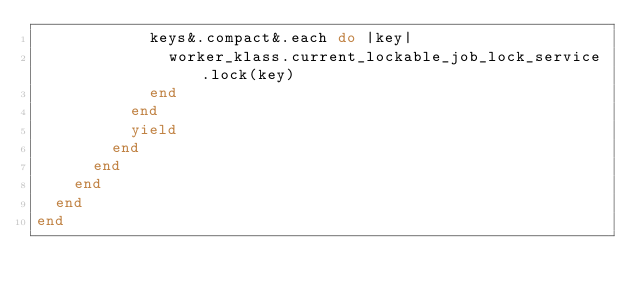Convert code to text. <code><loc_0><loc_0><loc_500><loc_500><_Ruby_>            keys&.compact&.each do |key|
              worker_klass.current_lockable_job_lock_service.lock(key)
            end
          end
          yield
        end
      end
    end
  end
end
</code> 